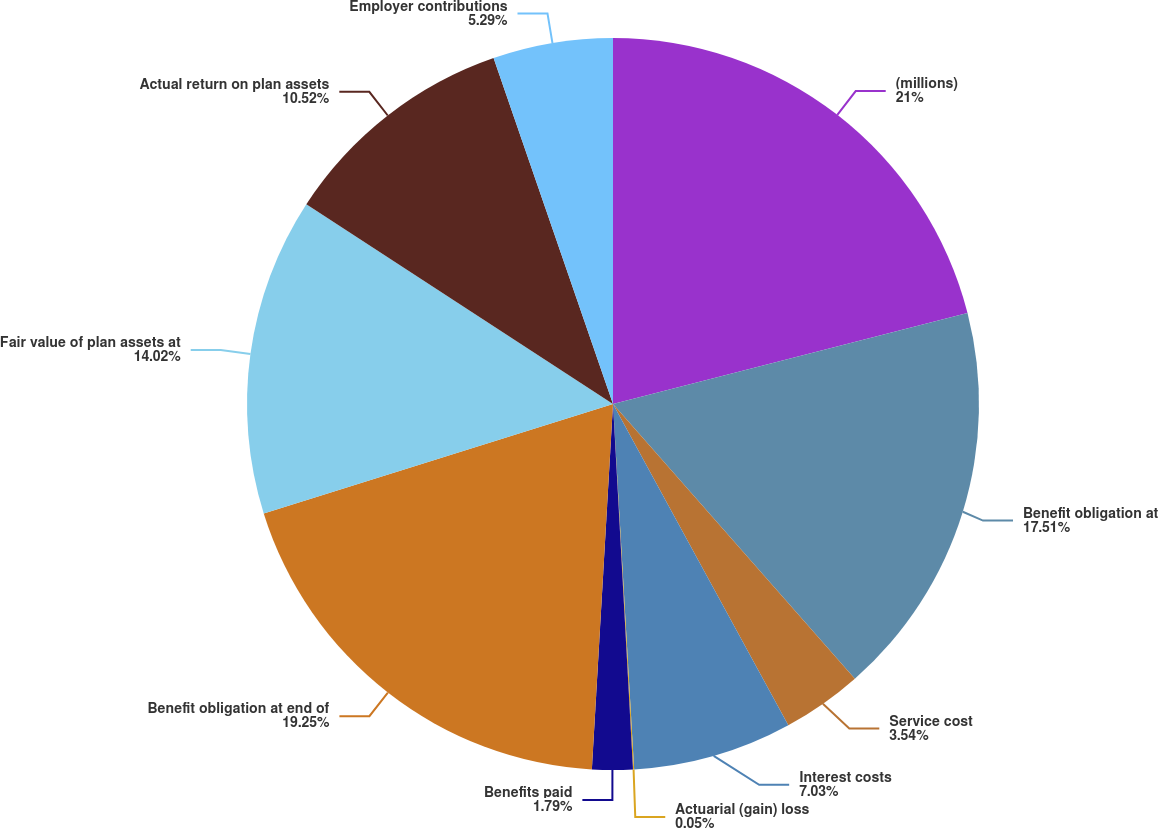<chart> <loc_0><loc_0><loc_500><loc_500><pie_chart><fcel>(millions)<fcel>Benefit obligation at<fcel>Service cost<fcel>Interest costs<fcel>Actuarial (gain) loss<fcel>Benefits paid<fcel>Benefit obligation at end of<fcel>Fair value of plan assets at<fcel>Actual return on plan assets<fcel>Employer contributions<nl><fcel>21.0%<fcel>17.51%<fcel>3.54%<fcel>7.03%<fcel>0.05%<fcel>1.79%<fcel>19.25%<fcel>14.02%<fcel>10.52%<fcel>5.29%<nl></chart> 